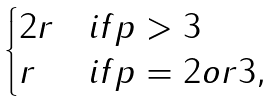<formula> <loc_0><loc_0><loc_500><loc_500>\begin{cases} 2 r & i f p > 3 \\ r & i f p = 2 o r 3 , \end{cases}</formula> 